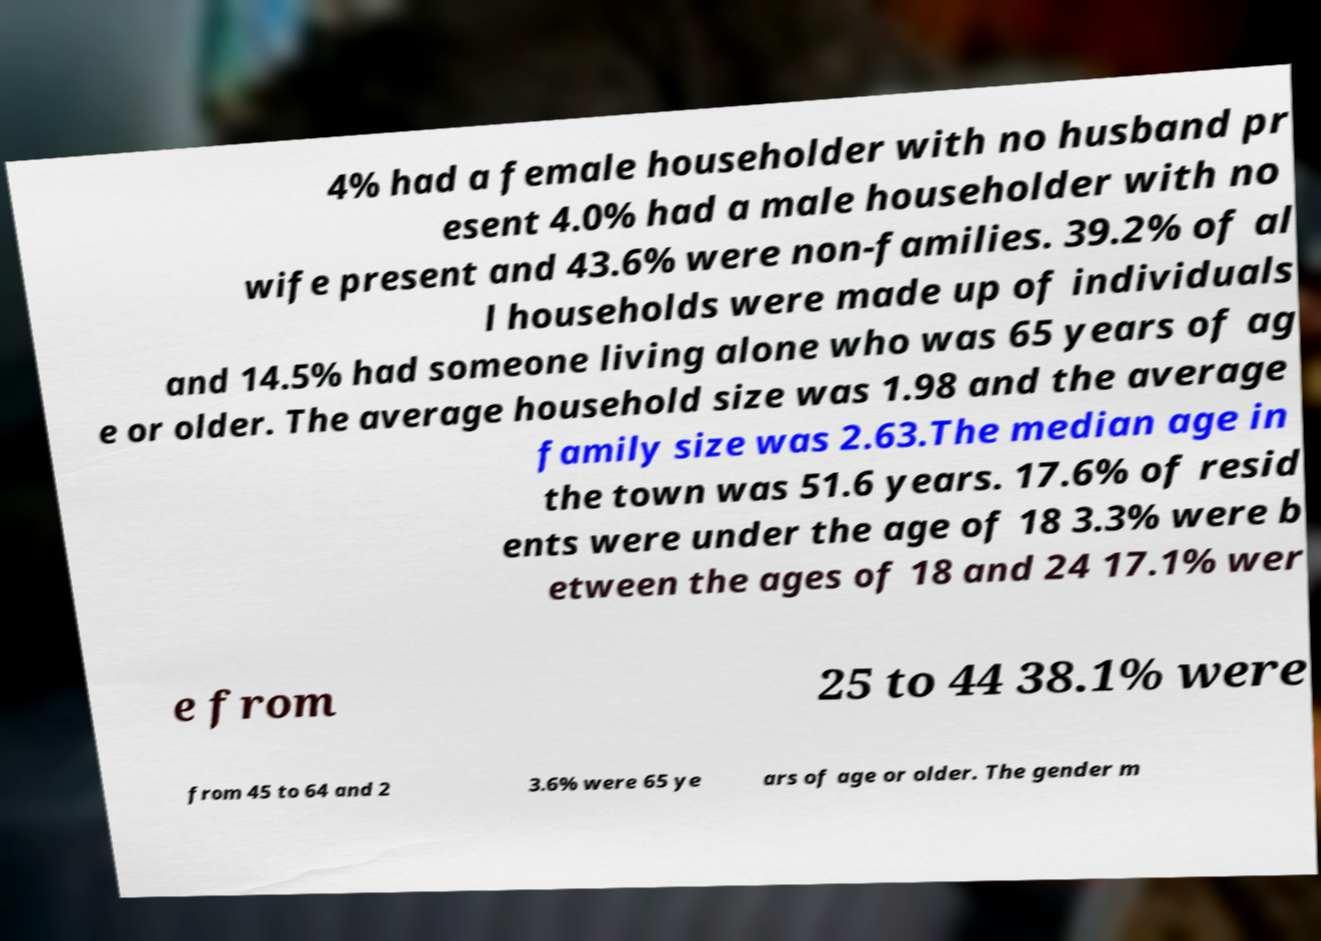Could you assist in decoding the text presented in this image and type it out clearly? 4% had a female householder with no husband pr esent 4.0% had a male householder with no wife present and 43.6% were non-families. 39.2% of al l households were made up of individuals and 14.5% had someone living alone who was 65 years of ag e or older. The average household size was 1.98 and the average family size was 2.63.The median age in the town was 51.6 years. 17.6% of resid ents were under the age of 18 3.3% were b etween the ages of 18 and 24 17.1% wer e from 25 to 44 38.1% were from 45 to 64 and 2 3.6% were 65 ye ars of age or older. The gender m 